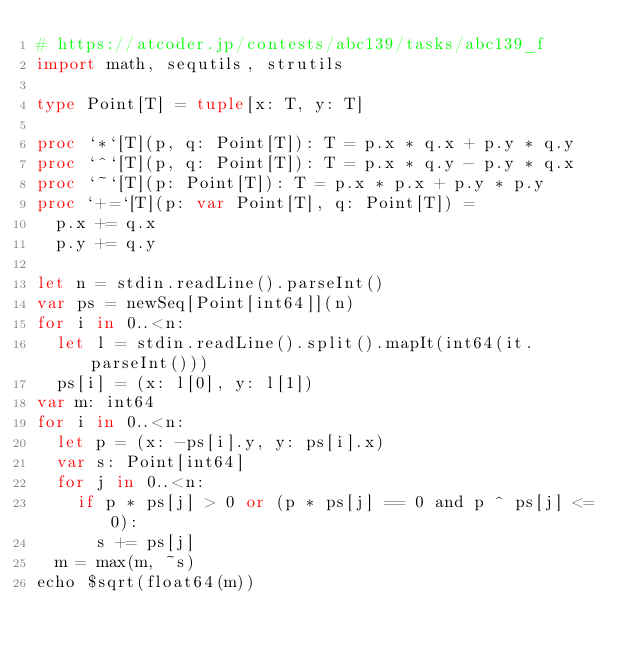Convert code to text. <code><loc_0><loc_0><loc_500><loc_500><_Nim_># https://atcoder.jp/contests/abc139/tasks/abc139_f
import math, sequtils, strutils

type Point[T] = tuple[x: T, y: T]

proc `*`[T](p, q: Point[T]): T = p.x * q.x + p.y * q.y
proc `^`[T](p, q: Point[T]): T = p.x * q.y - p.y * q.x
proc `~`[T](p: Point[T]): T = p.x * p.x + p.y * p.y
proc `+=`[T](p: var Point[T], q: Point[T]) =
  p.x += q.x
  p.y += q.y

let n = stdin.readLine().parseInt()
var ps = newSeq[Point[int64]](n)
for i in 0..<n:
  let l = stdin.readLine().split().mapIt(int64(it.parseInt()))
  ps[i] = (x: l[0], y: l[1])
var m: int64
for i in 0..<n:
  let p = (x: -ps[i].y, y: ps[i].x)
  var s: Point[int64]
  for j in 0..<n:
    if p * ps[j] > 0 or (p * ps[j] == 0 and p ^ ps[j] <= 0):
      s += ps[j]
  m = max(m, ~s)
echo $sqrt(float64(m))

</code> 